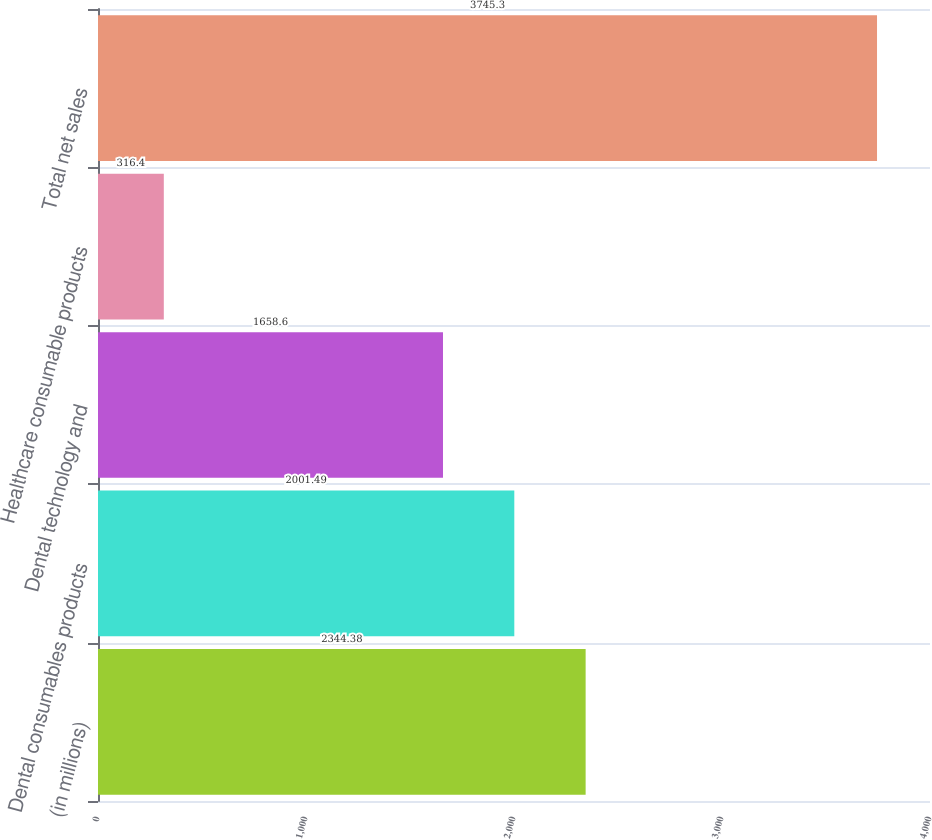Convert chart. <chart><loc_0><loc_0><loc_500><loc_500><bar_chart><fcel>(in millions)<fcel>Dental consumables products<fcel>Dental technology and<fcel>Healthcare consumable products<fcel>Total net sales<nl><fcel>2344.38<fcel>2001.49<fcel>1658.6<fcel>316.4<fcel>3745.3<nl></chart> 